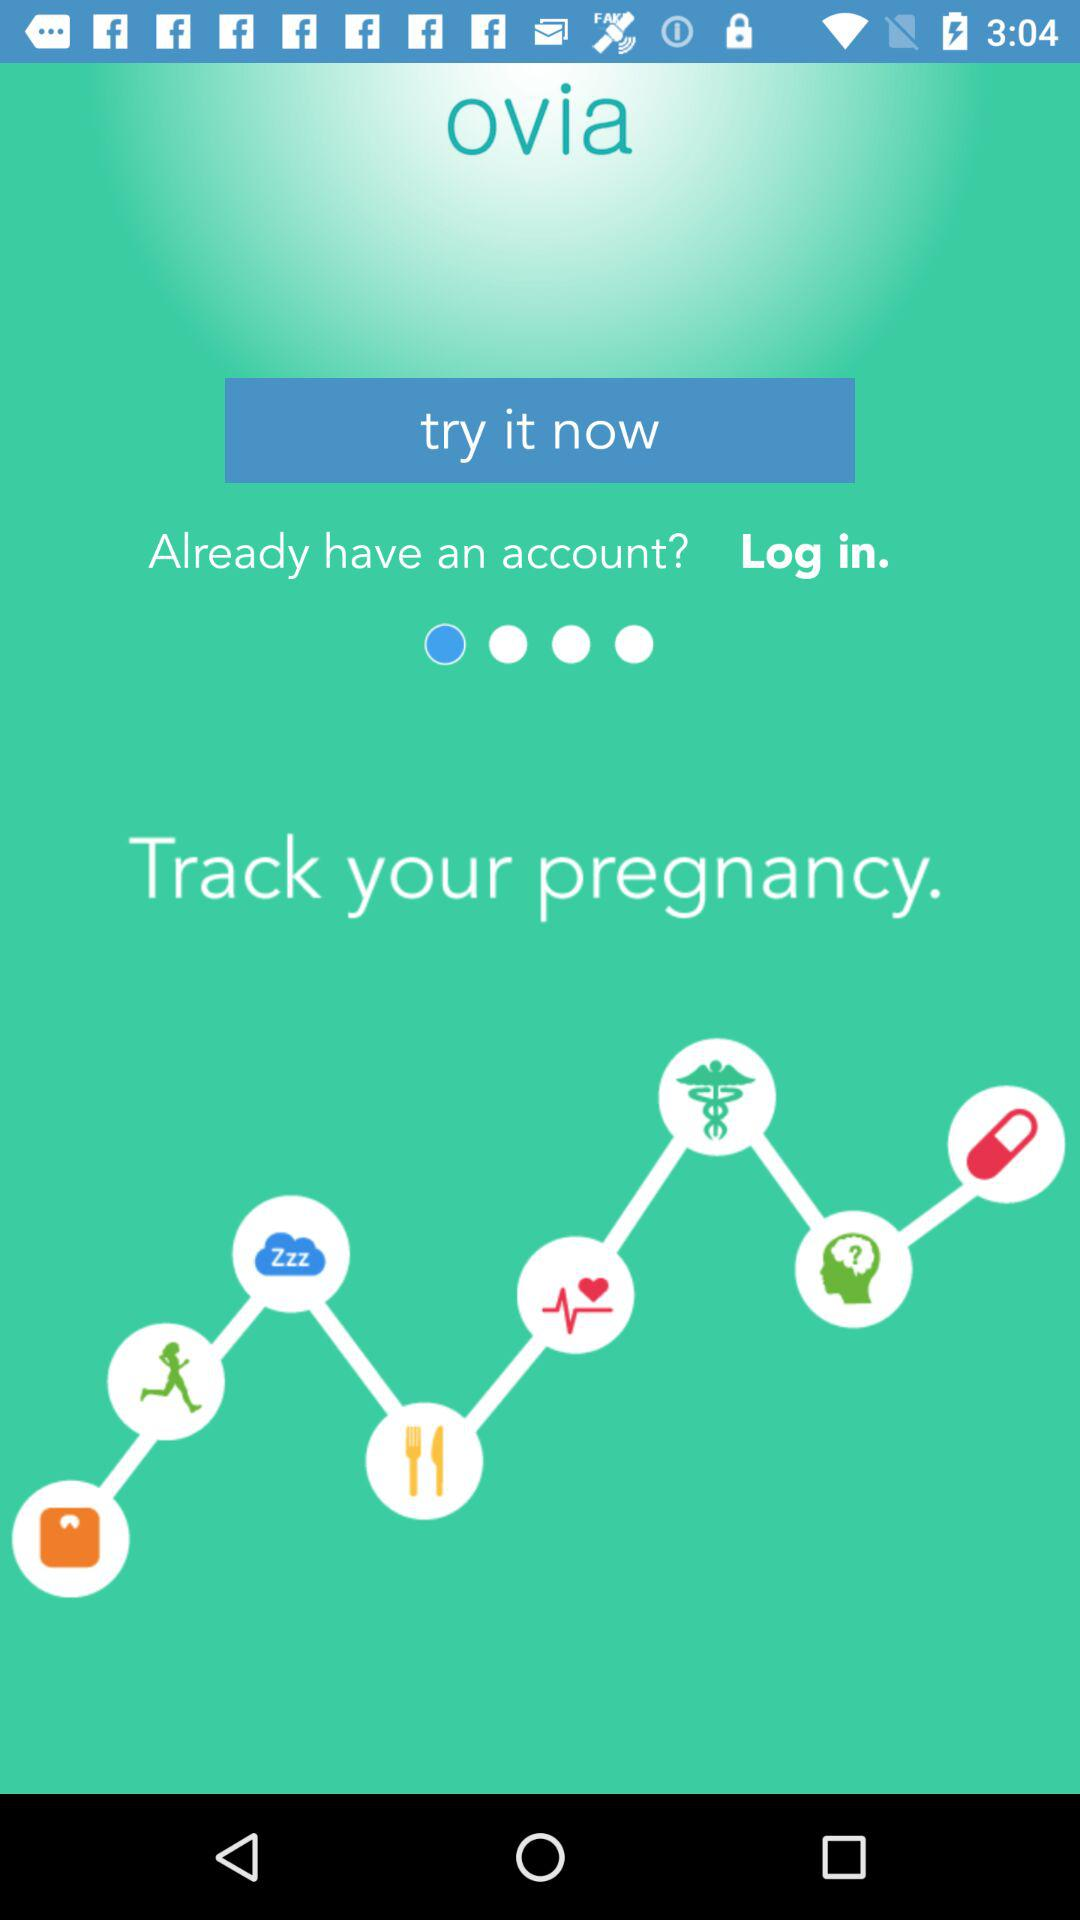What is the app name? The app name is "ovia". 